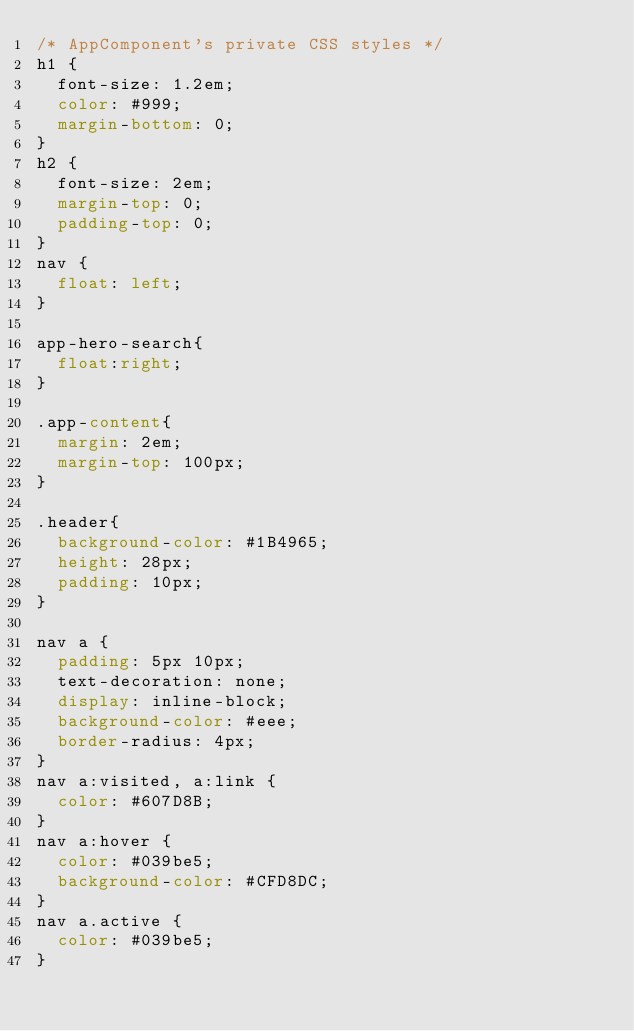Convert code to text. <code><loc_0><loc_0><loc_500><loc_500><_CSS_>/* AppComponent's private CSS styles */
h1 {
  font-size: 1.2em;
  color: #999;
  margin-bottom: 0;
}
h2 {
  font-size: 2em;
  margin-top: 0;
  padding-top: 0;
}
nav {
  float: left;
}

app-hero-search{
  float:right;
}

.app-content{
  margin: 2em;
  margin-top: 100px;
}

.header{
  background-color: #1B4965;
  height: 28px;
  padding: 10px;
}

nav a {
  padding: 5px 10px;
  text-decoration: none;
  display: inline-block;
  background-color: #eee;
  border-radius: 4px;
}
nav a:visited, a:link {
  color: #607D8B;
}
nav a:hover {
  color: #039be5;
  background-color: #CFD8DC;
}
nav a.active {
  color: #039be5;
}



</code> 